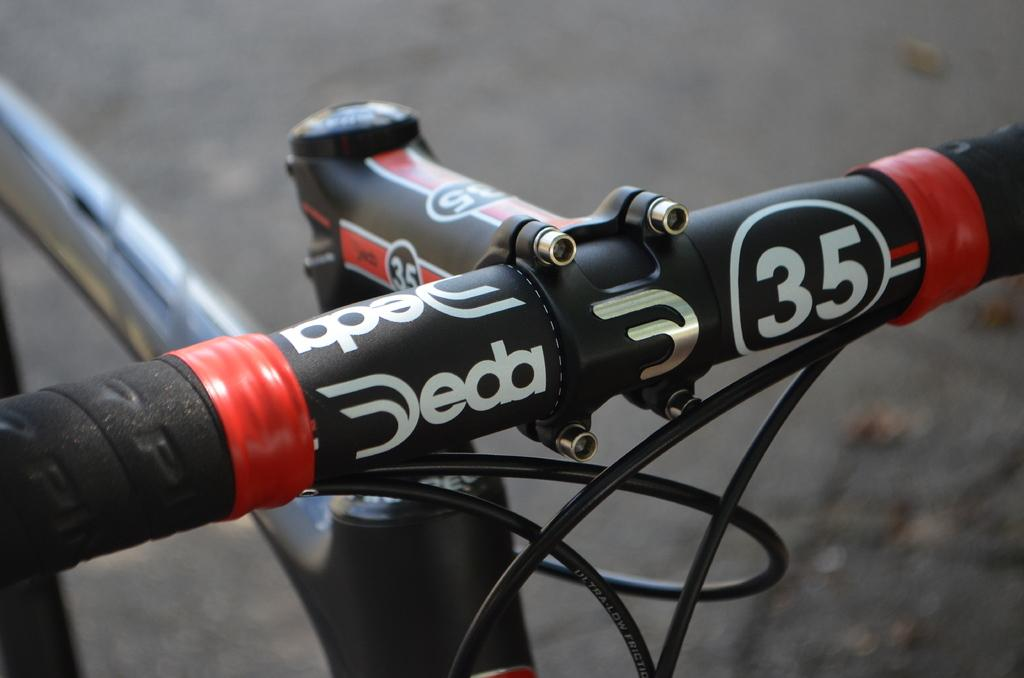What part of a bicycle can be seen in the image? There is a handle of a bicycle in the image. What else is visible in the image besides the bicycle handle? There are cables present in the image. How many cakes are visible in the image? There are no cakes present in the image. Can you see a window in the image? There is no window visible in the image. 